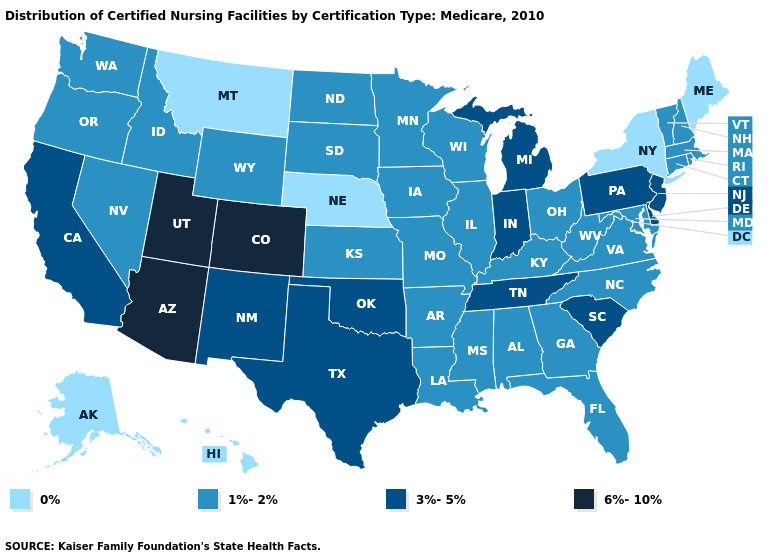Name the states that have a value in the range 0%?
Answer briefly. Alaska, Hawaii, Maine, Montana, Nebraska, New York. Which states have the highest value in the USA?
Quick response, please. Arizona, Colorado, Utah. Which states have the lowest value in the USA?
Answer briefly. Alaska, Hawaii, Maine, Montana, Nebraska, New York. Does Colorado have the highest value in the USA?
Be succinct. Yes. Name the states that have a value in the range 6%-10%?
Answer briefly. Arizona, Colorado, Utah. Name the states that have a value in the range 6%-10%?
Give a very brief answer. Arizona, Colorado, Utah. Does Georgia have the lowest value in the USA?
Answer briefly. No. Does the map have missing data?
Be succinct. No. Which states hav the highest value in the Northeast?
Write a very short answer. New Jersey, Pennsylvania. What is the value of Alaska?
Be succinct. 0%. Does Vermont have the lowest value in the Northeast?
Write a very short answer. No. What is the lowest value in states that border Idaho?
Short answer required. 0%. Does Minnesota have the same value as Iowa?
Answer briefly. Yes. 